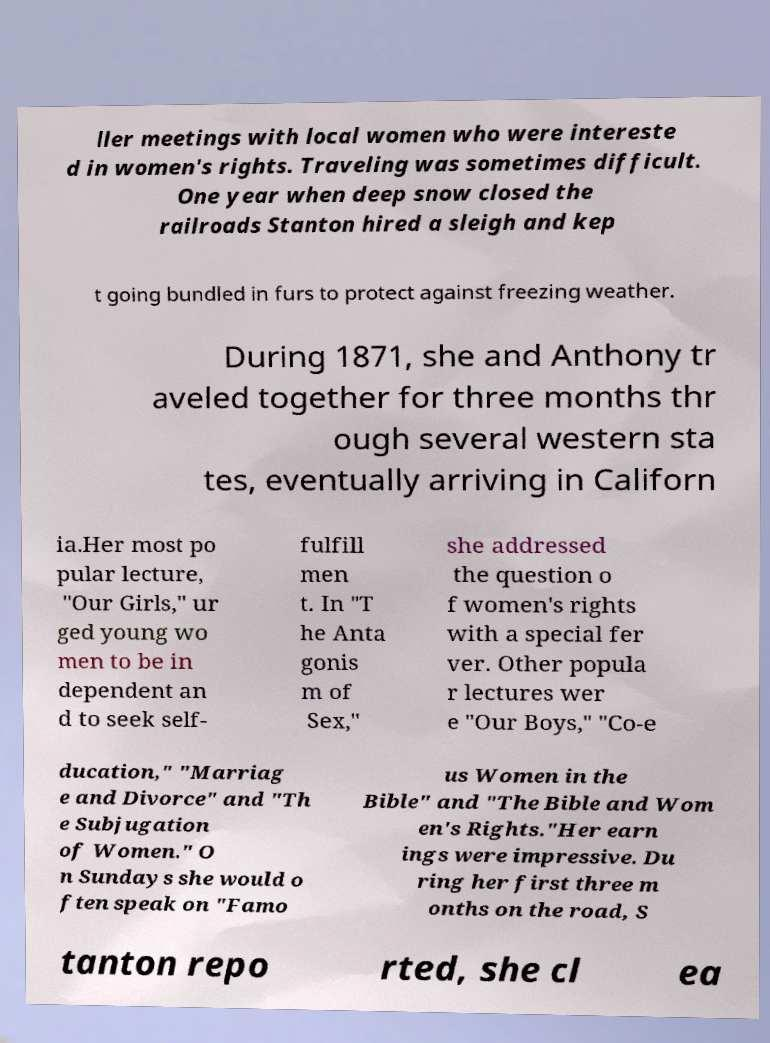Please identify and transcribe the text found in this image. ller meetings with local women who were intereste d in women's rights. Traveling was sometimes difficult. One year when deep snow closed the railroads Stanton hired a sleigh and kep t going bundled in furs to protect against freezing weather. During 1871, she and Anthony tr aveled together for three months thr ough several western sta tes, eventually arriving in Californ ia.Her most po pular lecture, "Our Girls," ur ged young wo men to be in dependent an d to seek self- fulfill men t. In "T he Anta gonis m of Sex," she addressed the question o f women's rights with a special fer ver. Other popula r lectures wer e "Our Boys," "Co-e ducation," "Marriag e and Divorce" and "Th e Subjugation of Women." O n Sundays she would o ften speak on "Famo us Women in the Bible" and "The Bible and Wom en's Rights."Her earn ings were impressive. Du ring her first three m onths on the road, S tanton repo rted, she cl ea 